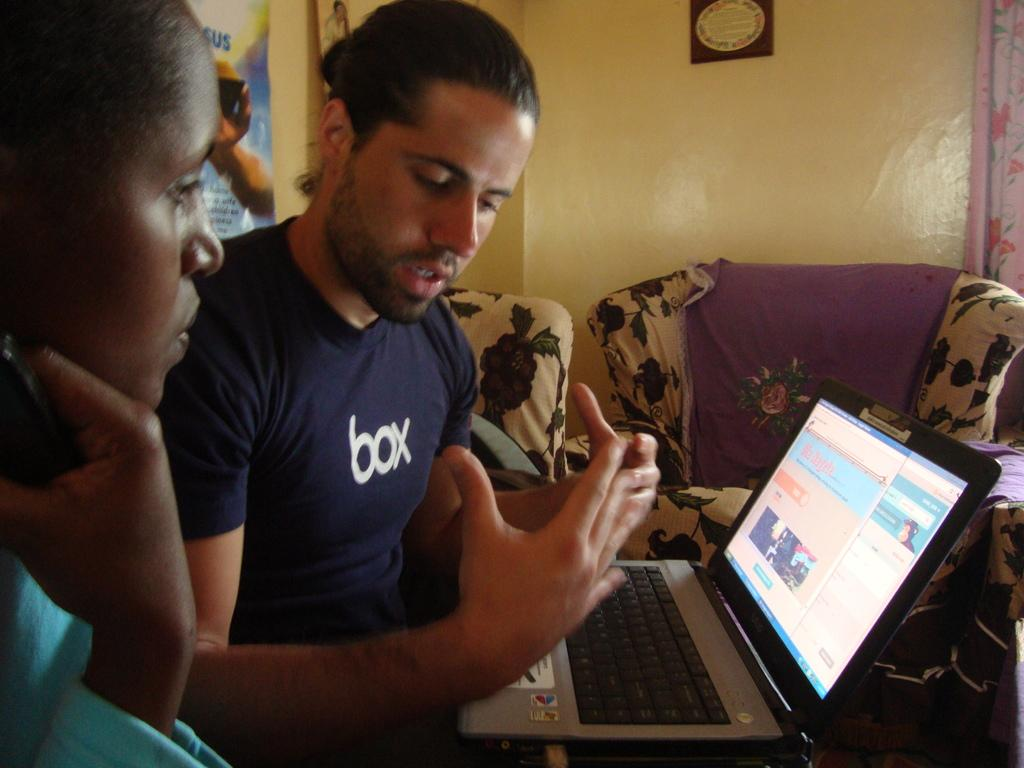Who is the main subject in the center of the image? There is a man in the center of the image. What is the man holding or using in the image? The man has a laptop on his lap. Who else can be seen in the image? There is a lady on the left side of the image. What type of furniture is visible in the background of the image? There are sofas in the background of the image. What decorative elements can be seen in the background of the image? There are posters in the background of the image. What type of window treatment is present in the background of the image? There is a curtain in the background of the image. What language is the man speaking to the lady in the image? There is no indication of any spoken language in the image, as it is a still photograph. 